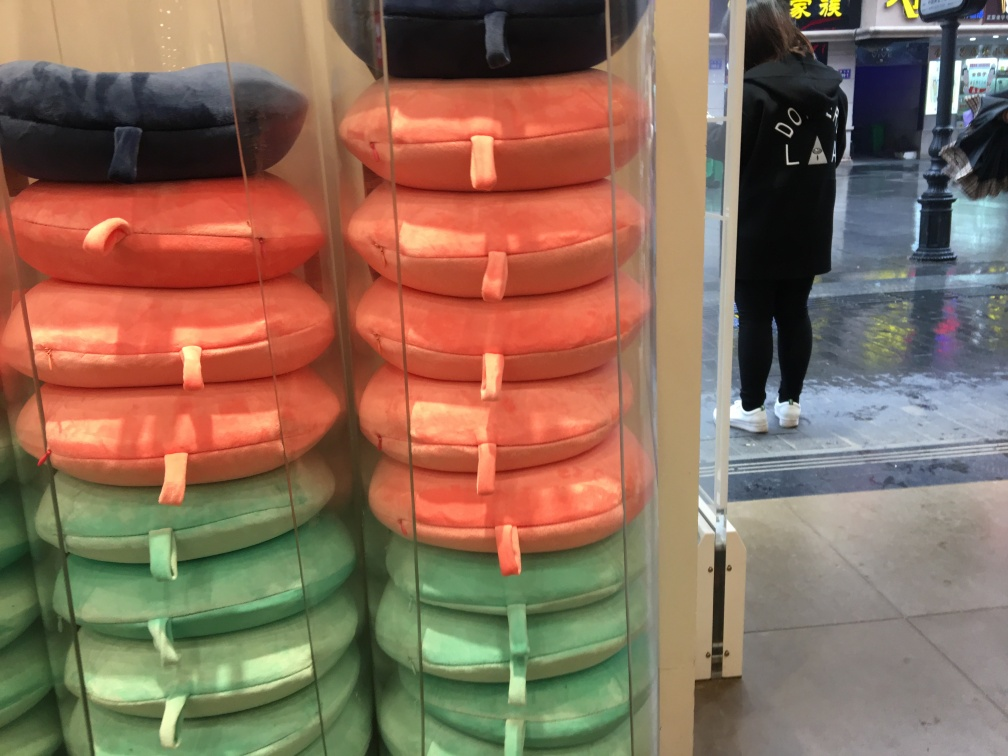Could you infer the location where this picture is taken? While the exact location is not overtly clear from the image, the context suggests it might be taken inside a retail store with travel accessories, possibly located in a busy urban area or inside a shopping mall. The reflection on the store's glass suggests a well-lit, possibly rainy urban environment outside. 